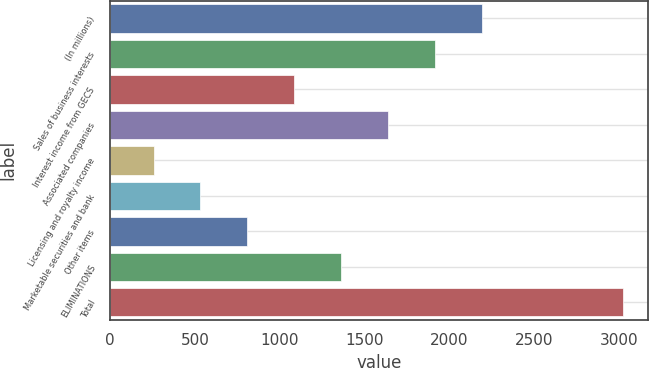<chart> <loc_0><loc_0><loc_500><loc_500><bar_chart><fcel>(In millions)<fcel>Sales of business interests<fcel>Interest income from GECS<fcel>Associated companies<fcel>Licensing and royalty income<fcel>Marketable securities and bank<fcel>Other items<fcel>ELIMINATIONS<fcel>Total<nl><fcel>2189.8<fcel>1913.4<fcel>1084.2<fcel>1637<fcel>255<fcel>531.4<fcel>807.8<fcel>1360.6<fcel>3019<nl></chart> 